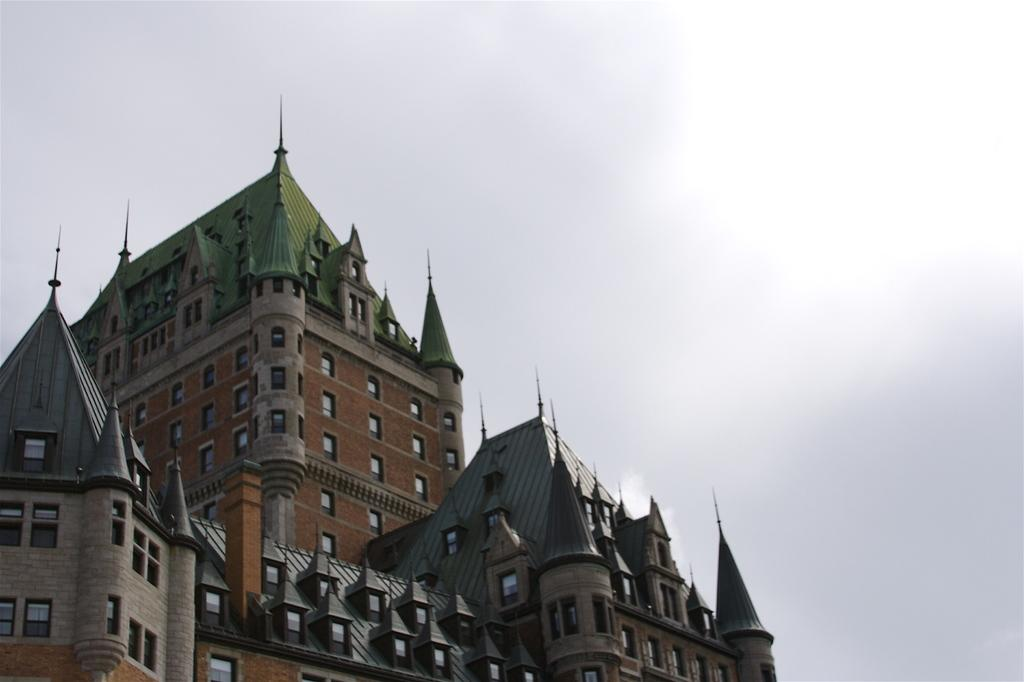What is the setting of the image? The image has an outside view. What is the main structure visible in the image? There is a castle in the foreground of the image. What can be seen in the distance in the image? The sky is visible in the background of the image. How many bears are visible in the image? There are no bears present in the image. What year is depicted in the image? The image does not depict a specific year; it is a photograph of a castle and the sky. 